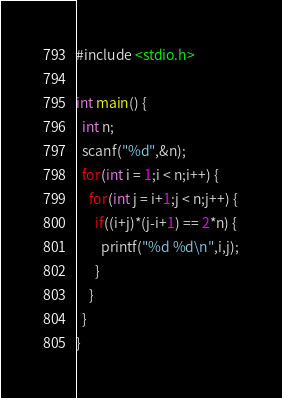<code> <loc_0><loc_0><loc_500><loc_500><_C++_>#include <stdio.h>

int main() {
  int n;
  scanf("%d",&n);
  for(int i = 1;i < n;i++) {
    for(int j = i+1;j < n;j++) {
      if((i+j)*(j-i+1) == 2*n) {
        printf("%d %d\n",i,j);
      }
    }
  }
}
</code> 